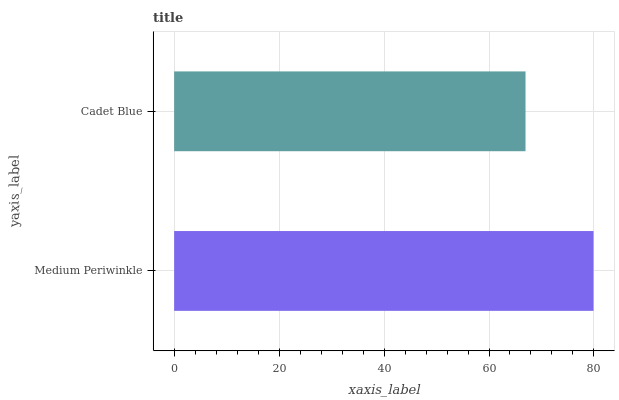Is Cadet Blue the minimum?
Answer yes or no. Yes. Is Medium Periwinkle the maximum?
Answer yes or no. Yes. Is Cadet Blue the maximum?
Answer yes or no. No. Is Medium Periwinkle greater than Cadet Blue?
Answer yes or no. Yes. Is Cadet Blue less than Medium Periwinkle?
Answer yes or no. Yes. Is Cadet Blue greater than Medium Periwinkle?
Answer yes or no. No. Is Medium Periwinkle less than Cadet Blue?
Answer yes or no. No. Is Medium Periwinkle the high median?
Answer yes or no. Yes. Is Cadet Blue the low median?
Answer yes or no. Yes. Is Cadet Blue the high median?
Answer yes or no. No. Is Medium Periwinkle the low median?
Answer yes or no. No. 